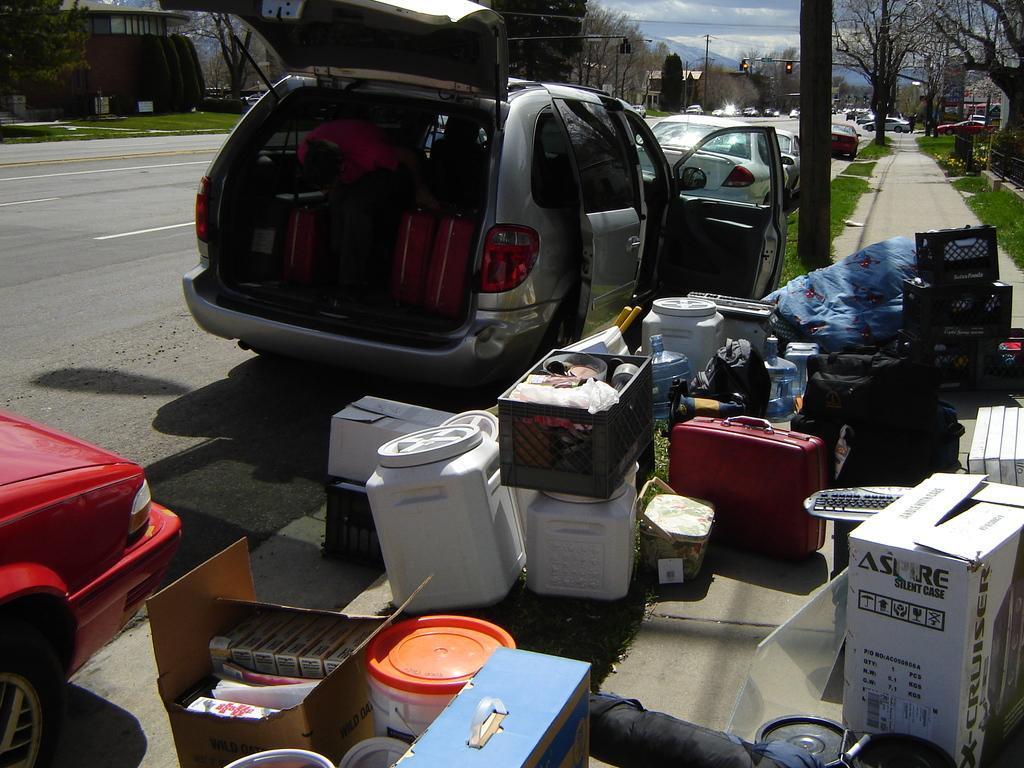Can you describe this image briefly? This is an outside view. Here I can see many boxes, luggage bags, card boxes and some other objects are placed on the footpath. On the left side there are many vehicles on the road. On both sides of the road there are many trees, light poles and buildings. At the top of the image I can see the sky. 